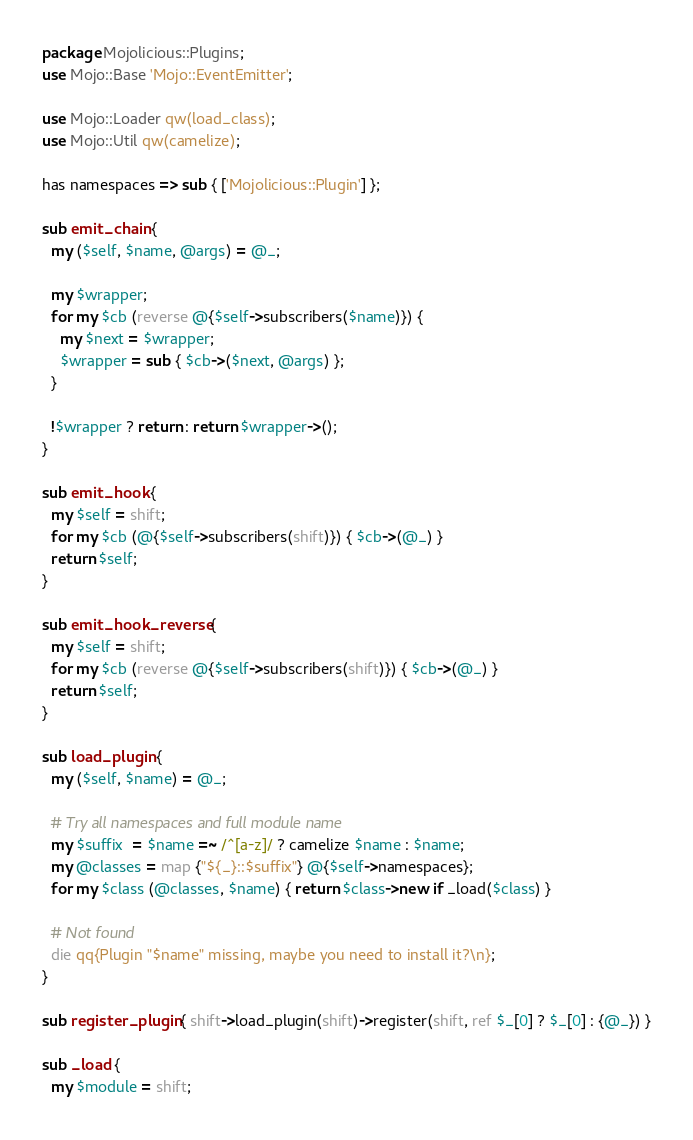Convert code to text. <code><loc_0><loc_0><loc_500><loc_500><_Perl_>package Mojolicious::Plugins;
use Mojo::Base 'Mojo::EventEmitter';

use Mojo::Loader qw(load_class);
use Mojo::Util qw(camelize);

has namespaces => sub { ['Mojolicious::Plugin'] };

sub emit_chain {
  my ($self, $name, @args) = @_;

  my $wrapper;
  for my $cb (reverse @{$self->subscribers($name)}) {
    my $next = $wrapper;
    $wrapper = sub { $cb->($next, @args) };
  }

  !$wrapper ? return : return $wrapper->();
}

sub emit_hook {
  my $self = shift;
  for my $cb (@{$self->subscribers(shift)}) { $cb->(@_) }
  return $self;
}

sub emit_hook_reverse {
  my $self = shift;
  for my $cb (reverse @{$self->subscribers(shift)}) { $cb->(@_) }
  return $self;
}

sub load_plugin {
  my ($self, $name) = @_;

  # Try all namespaces and full module name
  my $suffix  = $name =~ /^[a-z]/ ? camelize $name : $name;
  my @classes = map {"${_}::$suffix"} @{$self->namespaces};
  for my $class (@classes, $name) { return $class->new if _load($class) }

  # Not found
  die qq{Plugin "$name" missing, maybe you need to install it?\n};
}

sub register_plugin { shift->load_plugin(shift)->register(shift, ref $_[0] ? $_[0] : {@_}) }

sub _load {
  my $module = shift;</code> 